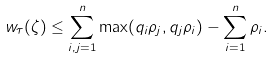Convert formula to latex. <formula><loc_0><loc_0><loc_500><loc_500>w _ { \tau } ( \zeta ) \leq \sum _ { i , j = 1 } ^ { n } \max ( q _ { i } \rho _ { j } , q _ { j } \rho _ { i } ) - \sum _ { i = 1 } ^ { n } \rho _ { i } .</formula> 